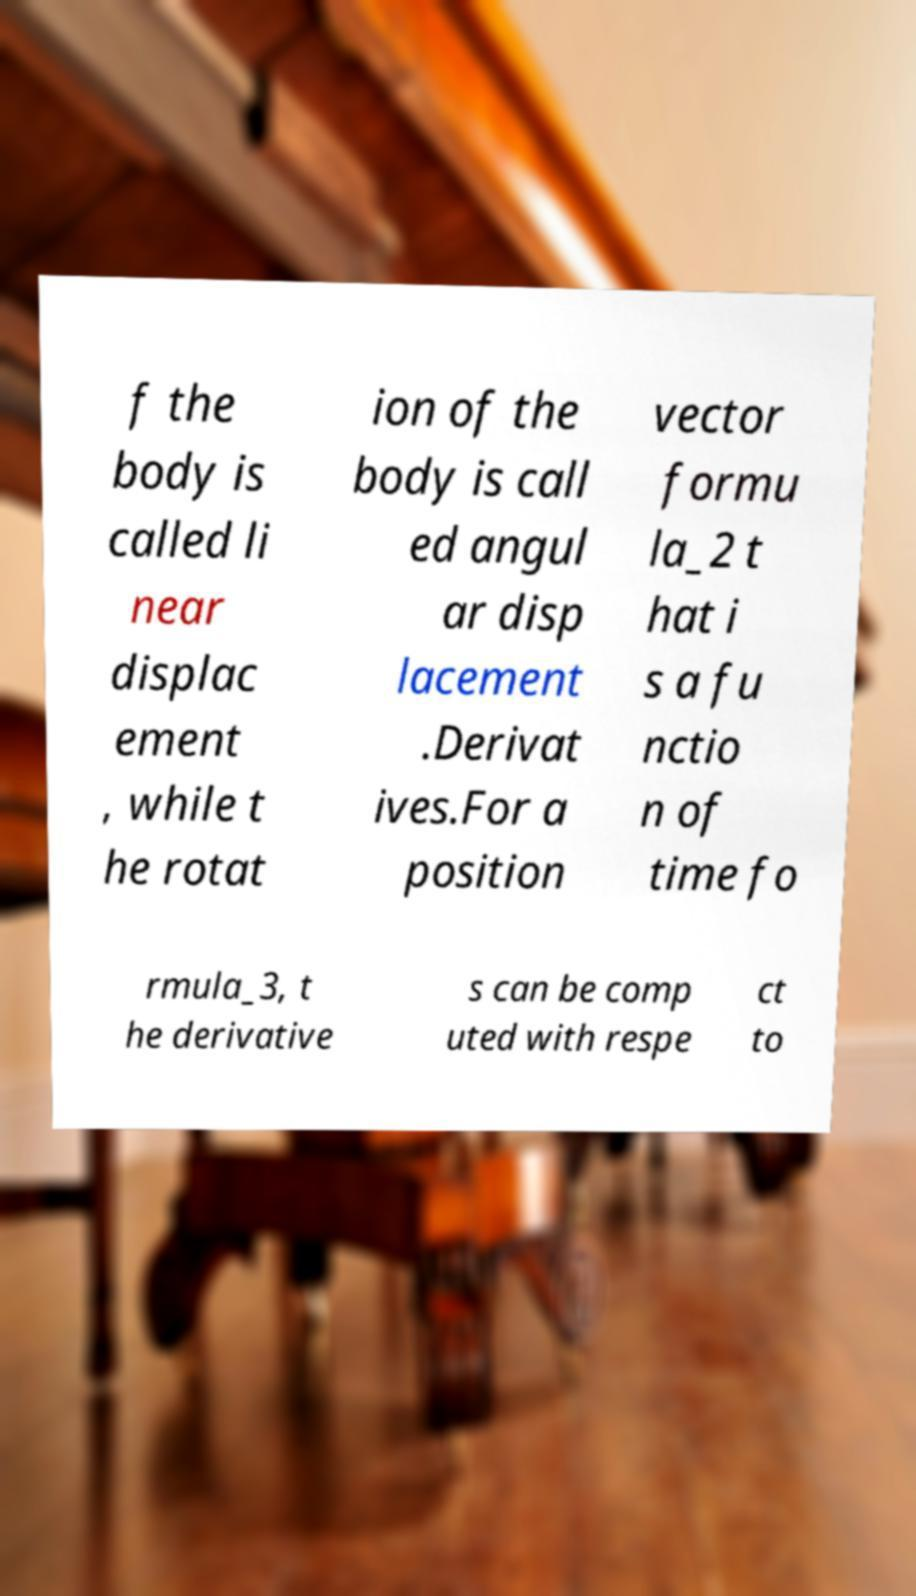For documentation purposes, I need the text within this image transcribed. Could you provide that? f the body is called li near displac ement , while t he rotat ion of the body is call ed angul ar disp lacement .Derivat ives.For a position vector formu la_2 t hat i s a fu nctio n of time fo rmula_3, t he derivative s can be comp uted with respe ct to 